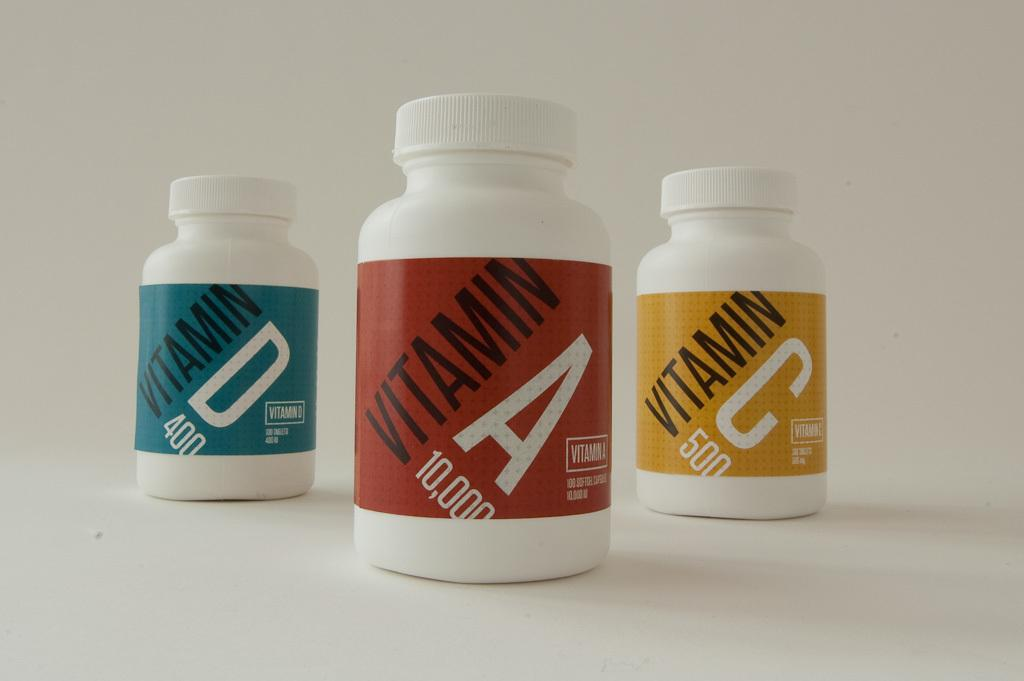<image>
Summarize the visual content of the image. Three vottles with different color labels of Vitamin, D, A and C. 